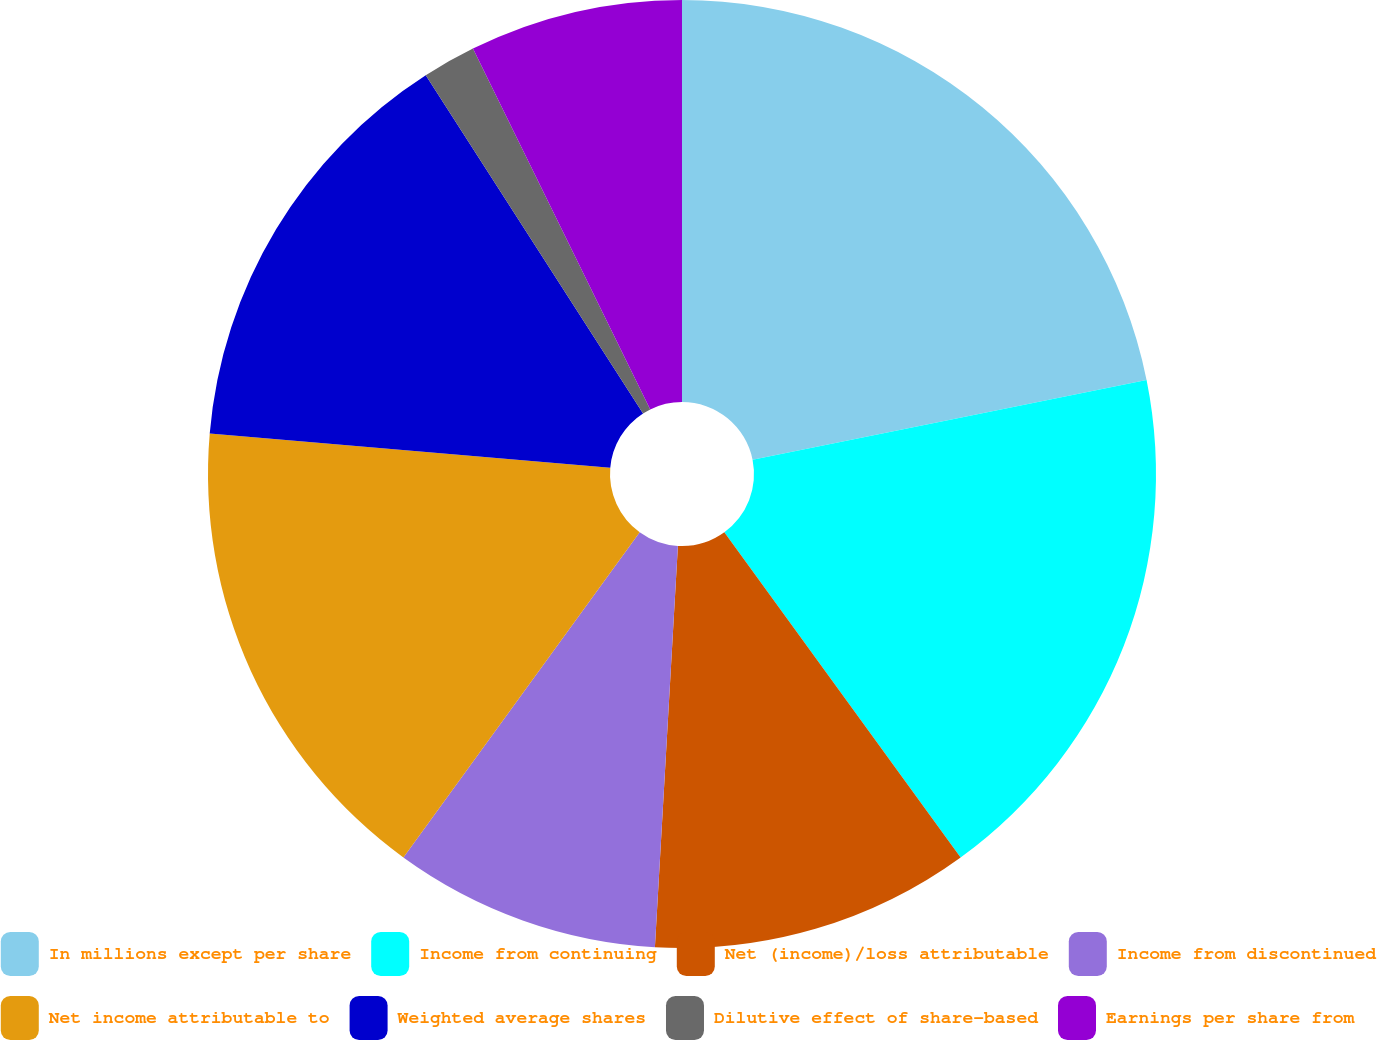Convert chart to OTSL. <chart><loc_0><loc_0><loc_500><loc_500><pie_chart><fcel>In millions except per share<fcel>Income from continuing<fcel>Net (income)/loss attributable<fcel>Income from discontinued<fcel>Net income attributable to<fcel>Weighted average shares<fcel>Dilutive effect of share-based<fcel>Earnings per share from<nl><fcel>21.82%<fcel>18.18%<fcel>10.91%<fcel>9.09%<fcel>16.36%<fcel>14.55%<fcel>1.82%<fcel>7.27%<nl></chart> 